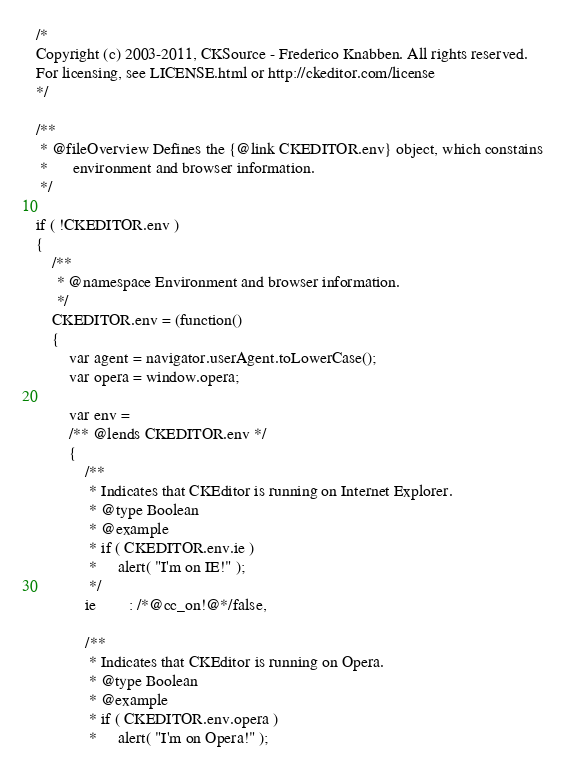Convert code to text. <code><loc_0><loc_0><loc_500><loc_500><_JavaScript_>/*
Copyright (c) 2003-2011, CKSource - Frederico Knabben. All rights reserved.
For licensing, see LICENSE.html or http://ckeditor.com/license
*/

/**
 * @fileOverview Defines the {@link CKEDITOR.env} object, which constains
 *		environment and browser information.
 */

if ( !CKEDITOR.env )
{
	/**
	 * @namespace Environment and browser information.
	 */
	CKEDITOR.env = (function()
	{
		var agent = navigator.userAgent.toLowerCase();
		var opera = window.opera;

		var env =
		/** @lends CKEDITOR.env */
		{
			/**
			 * Indicates that CKEditor is running on Internet Explorer.
			 * @type Boolean
			 * @example
			 * if ( CKEDITOR.env.ie )
			 *     alert( "I'm on IE!" );
			 */
			ie		: /*@cc_on!@*/false,

			/**
			 * Indicates that CKEditor is running on Opera.
			 * @type Boolean
			 * @example
			 * if ( CKEDITOR.env.opera )
			 *     alert( "I'm on Opera!" );</code> 